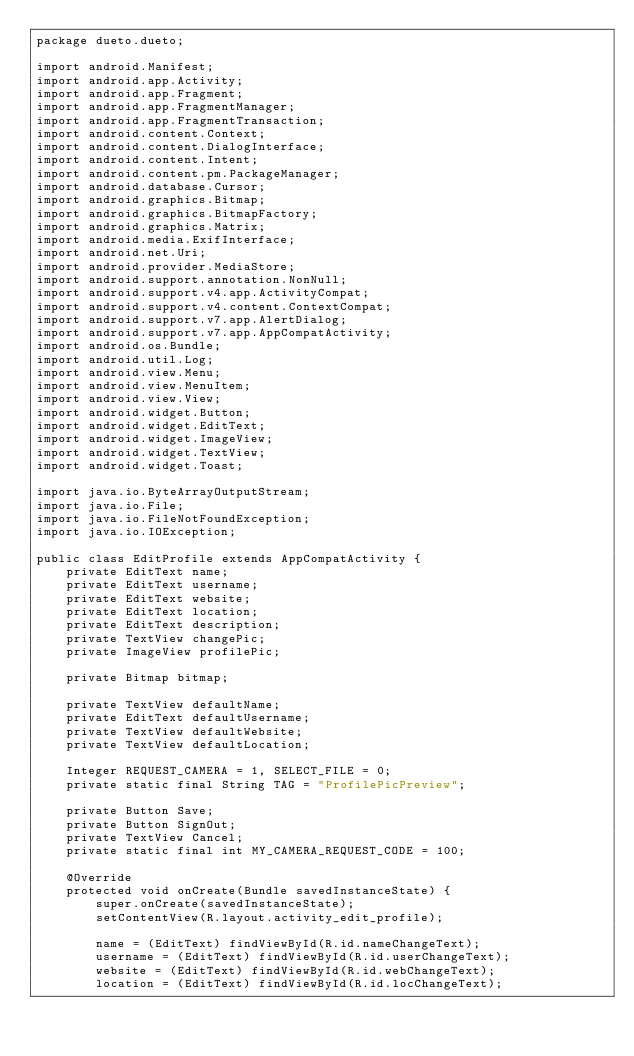<code> <loc_0><loc_0><loc_500><loc_500><_Java_>package dueto.dueto;

import android.Manifest;
import android.app.Activity;
import android.app.Fragment;
import android.app.FragmentManager;
import android.app.FragmentTransaction;
import android.content.Context;
import android.content.DialogInterface;
import android.content.Intent;
import android.content.pm.PackageManager;
import android.database.Cursor;
import android.graphics.Bitmap;
import android.graphics.BitmapFactory;
import android.graphics.Matrix;
import android.media.ExifInterface;
import android.net.Uri;
import android.provider.MediaStore;
import android.support.annotation.NonNull;
import android.support.v4.app.ActivityCompat;
import android.support.v4.content.ContextCompat;
import android.support.v7.app.AlertDialog;
import android.support.v7.app.AppCompatActivity;
import android.os.Bundle;
import android.util.Log;
import android.view.Menu;
import android.view.MenuItem;
import android.view.View;
import android.widget.Button;
import android.widget.EditText;
import android.widget.ImageView;
import android.widget.TextView;
import android.widget.Toast;

import java.io.ByteArrayOutputStream;
import java.io.File;
import java.io.FileNotFoundException;
import java.io.IOException;

public class EditProfile extends AppCompatActivity {
    private EditText name;
    private EditText username;
    private EditText website;
    private EditText location;
    private EditText description;
    private TextView changePic;
    private ImageView profilePic;

    private Bitmap bitmap;

    private TextView defaultName;
    private EditText defaultUsername;
    private TextView defaultWebsite;
    private TextView defaultLocation;

    Integer REQUEST_CAMERA = 1, SELECT_FILE = 0;
    private static final String TAG = "ProfilePicPreview";

    private Button Save;
    private Button SignOut;
    private TextView Cancel;
    private static final int MY_CAMERA_REQUEST_CODE = 100;

    @Override
    protected void onCreate(Bundle savedInstanceState) {
        super.onCreate(savedInstanceState);
        setContentView(R.layout.activity_edit_profile);

        name = (EditText) findViewById(R.id.nameChangeText);
        username = (EditText) findViewById(R.id.userChangeText);
        website = (EditText) findViewById(R.id.webChangeText);
        location = (EditText) findViewById(R.id.locChangeText);</code> 